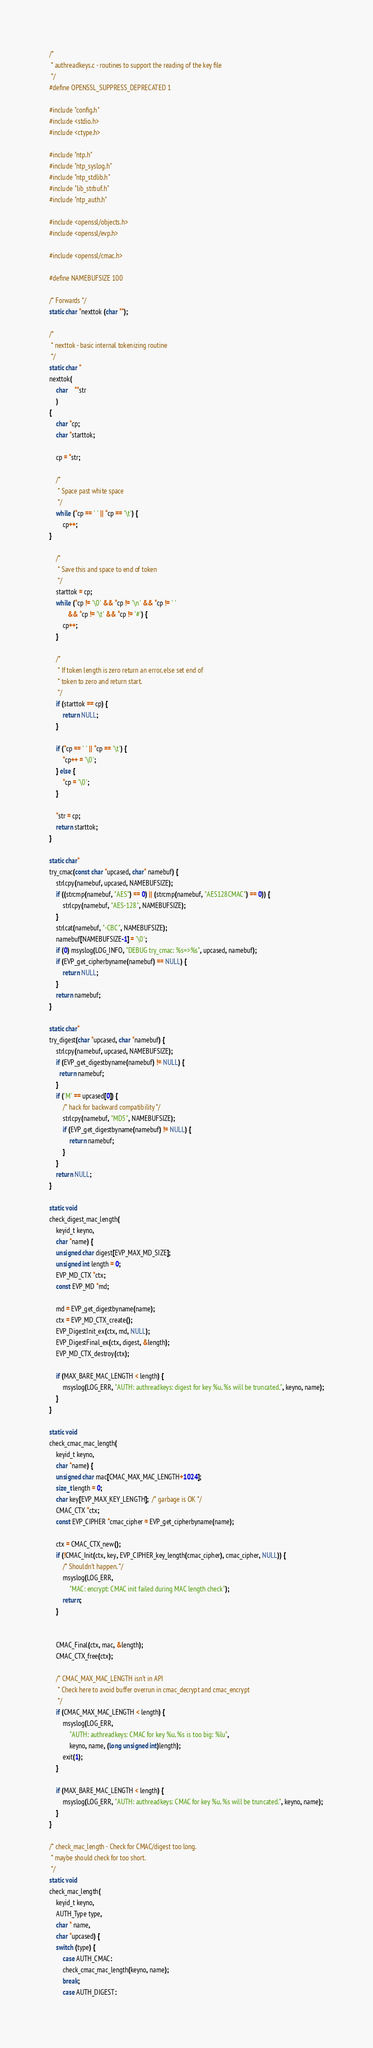<code> <loc_0><loc_0><loc_500><loc_500><_C_>/*
 * authreadkeys.c - routines to support the reading of the key file
 */
#define OPENSSL_SUPPRESS_DEPRECATED 1

#include "config.h"
#include <stdio.h>
#include <ctype.h>

#include "ntp.h"
#include "ntp_syslog.h"
#include "ntp_stdlib.h"
#include "lib_strbuf.h"
#include "ntp_auth.h"

#include <openssl/objects.h>
#include <openssl/evp.h>

#include <openssl/cmac.h>

#define NAMEBUFSIZE 100

/* Forwards */
static char *nexttok (char **);

/*
 * nexttok - basic internal tokenizing routine
 */
static char *
nexttok(
	char	**str
	)
{
	char *cp;
	char *starttok;

	cp = *str;

	/*
	 * Space past white space
	 */
	while (*cp == ' ' || *cp == '\t') {
		cp++;
}

	/*
	 * Save this and space to end of token
	 */
	starttok = cp;
	while (*cp != '\0' && *cp != '\n' && *cp != ' '
	       && *cp != '\t' && *cp != '#') {
		cp++;
	}

	/*
	 * If token length is zero return an error, else set end of
	 * token to zero and return start.
	 */
	if (starttok == cp) {
		return NULL;
	}

	if (*cp == ' ' || *cp == '\t') {
		*cp++ = '\0';
	} else {
		*cp = '\0';
	}

	*str = cp;
	return starttok;
}

static char*
try_cmac(const char *upcased, char* namebuf) {
	strlcpy(namebuf, upcased, NAMEBUFSIZE);
	if ((strcmp(namebuf, "AES") == 0) || (strcmp(namebuf, "AES128CMAC") == 0)) {
		strlcpy(namebuf, "AES-128", NAMEBUFSIZE);
	}
	strlcat(namebuf, "-CBC", NAMEBUFSIZE);
	namebuf[NAMEBUFSIZE-1] = '\0';
	if (0) msyslog(LOG_INFO, "DEBUG try_cmac: %s=>%s", upcased, namebuf);
	if (EVP_get_cipherbyname(namebuf) == NULL) {
		return NULL;
	}
	return namebuf;
}

static char*
try_digest(char *upcased, char *namebuf) {
	strlcpy(namebuf, upcased, NAMEBUFSIZE);
	if (EVP_get_digestbyname(namebuf) != NULL) {
	  return namebuf;
	}
	if ('M' == upcased[0]) {
		/* hack for backward compatibility */
		strlcpy(namebuf, "MD5", NAMEBUFSIZE);
		if (EVP_get_digestbyname(namebuf) != NULL) {
	 		return namebuf;
		}
	}
	return NULL;
}

static void
check_digest_mac_length(
	keyid_t keyno,
	char *name) {
	unsigned char digest[EVP_MAX_MD_SIZE];
	unsigned int length = 0;
	EVP_MD_CTX *ctx;
	const EVP_MD *md;

	md = EVP_get_digestbyname(name);
	ctx = EVP_MD_CTX_create();
	EVP_DigestInit_ex(ctx, md, NULL);
	EVP_DigestFinal_ex(ctx, digest, &length);
	EVP_MD_CTX_destroy(ctx);

	if (MAX_BARE_MAC_LENGTH < length) {
		msyslog(LOG_ERR, "AUTH: authreadkeys: digest for key %u, %s will be truncated.", keyno, name);
	}
}

static void
check_cmac_mac_length(
	keyid_t keyno,
	char *name) {
	unsigned char mac[CMAC_MAX_MAC_LENGTH+1024];
	size_t length = 0;
	char key[EVP_MAX_KEY_LENGTH];  /* garbage is OK */
	CMAC_CTX *ctx;
	const EVP_CIPHER *cmac_cipher = EVP_get_cipherbyname(name);

	ctx = CMAC_CTX_new();
	if (!CMAC_Init(ctx, key, EVP_CIPHER_key_length(cmac_cipher), cmac_cipher, NULL)) {
		/* Shouldn't happen. */
		msyslog(LOG_ERR,
			"MAC: encrypt: CMAC init failed during MAC length check");
		return;
	}


	CMAC_Final(ctx, mac, &length);
	CMAC_CTX_free(ctx);

	/* CMAC_MAX_MAC_LENGTH isn't in API
	 * Check here to avoid buffer overrun in cmac_decrypt and cmac_encrypt
	 */
	if (CMAC_MAX_MAC_LENGTH < length) {
		msyslog(LOG_ERR,
			"AUTH: authreadkeys: CMAC for key %u, %s is too big: %lu",
			keyno, name, (long unsigned int)length);
		exit(1);
	}

	if (MAX_BARE_MAC_LENGTH < length) {
		msyslog(LOG_ERR, "AUTH: authreadkeys: CMAC for key %u, %s will be truncated.", keyno, name);
	}
}

/* check_mac_length - Check for CMAC/digest too long.
 * maybe should check for too short.
 */
static void
check_mac_length(
	keyid_t keyno,
	AUTH_Type type,
	char * name,
	char *upcased) {
	switch (type) {
	    case AUTH_CMAC:
		check_cmac_mac_length(keyno, name);
		break;
	    case AUTH_DIGEST:</code> 